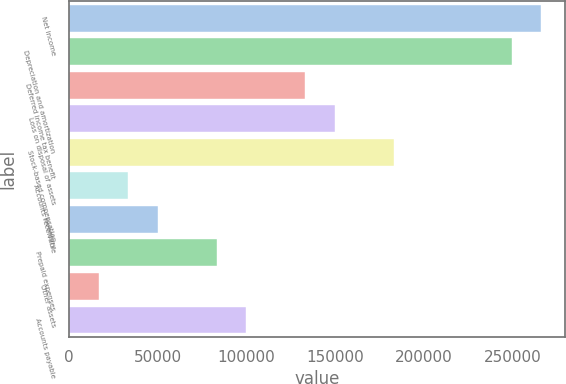<chart> <loc_0><loc_0><loc_500><loc_500><bar_chart><fcel>Net income<fcel>Depreciation and amortization<fcel>Deferred income tax benefit<fcel>Loss on disposal of assets<fcel>Stock-based compensation<fcel>Accounts receivable<fcel>Inventory<fcel>Prepaid expenses<fcel>Other assets<fcel>Accounts payable<nl><fcel>265898<fcel>249284<fcel>132985<fcel>149599<fcel>182827<fcel>33299.4<fcel>49913.6<fcel>83142<fcel>16685.2<fcel>99756.2<nl></chart> 